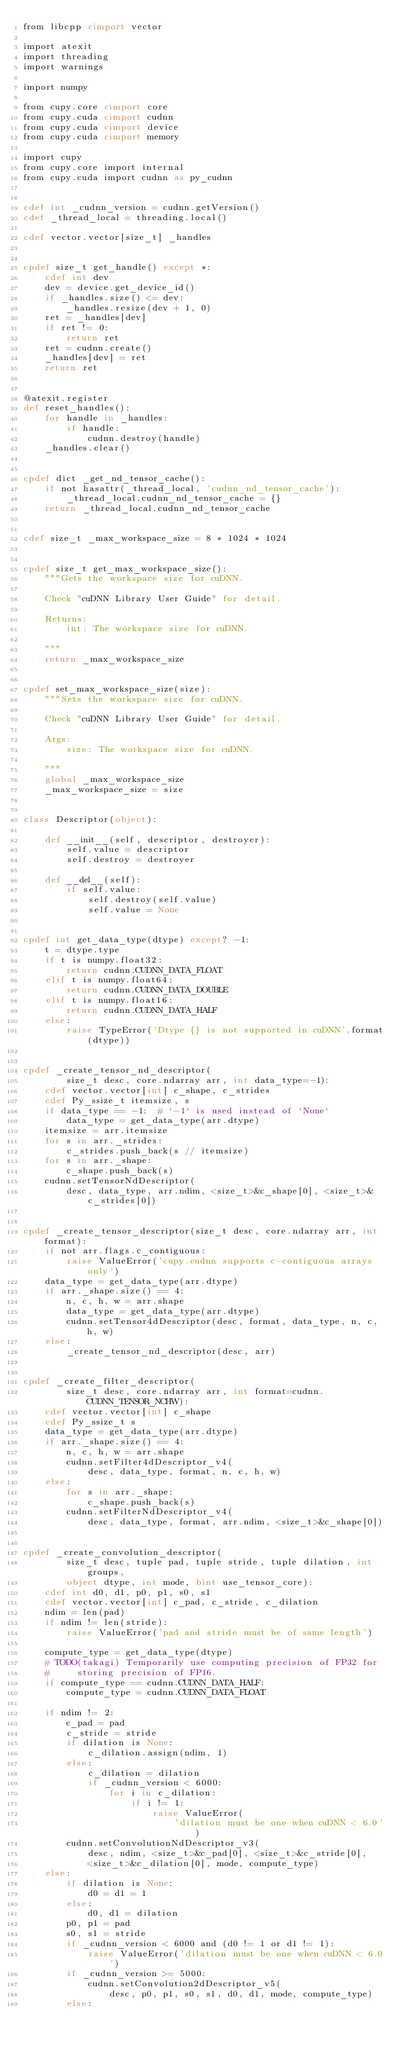<code> <loc_0><loc_0><loc_500><loc_500><_Cython_>from libcpp cimport vector

import atexit
import threading
import warnings

import numpy

from cupy.core cimport core
from cupy.cuda cimport cudnn
from cupy.cuda cimport device
from cupy.cuda cimport memory

import cupy
from cupy.core import internal
from cupy.cuda import cudnn as py_cudnn


cdef int _cudnn_version = cudnn.getVersion()
cdef _thread_local = threading.local()

cdef vector.vector[size_t] _handles


cpdef size_t get_handle() except *:
    cdef int dev
    dev = device.get_device_id()
    if _handles.size() <= dev:
        _handles.resize(dev + 1, 0)
    ret = _handles[dev]
    if ret != 0:
        return ret
    ret = cudnn.create()
    _handles[dev] = ret
    return ret


@atexit.register
def reset_handles():
    for handle in _handles:
        if handle:
            cudnn.destroy(handle)
    _handles.clear()


cpdef dict _get_nd_tensor_cache():
    if not hasattr(_thread_local, 'cudnn_nd_tensor_cache'):
        _thread_local.cudnn_nd_tensor_cache = {}
    return _thread_local.cudnn_nd_tensor_cache


cdef size_t _max_workspace_size = 8 * 1024 * 1024


cpdef size_t get_max_workspace_size():
    """Gets the workspace size for cuDNN.

    Check "cuDNN Library User Guide" for detail.

    Returns:
        int: The workspace size for cuDNN.

    """
    return _max_workspace_size


cpdef set_max_workspace_size(size):
    """Sets the workspace size for cuDNN.

    Check "cuDNN Library User Guide" for detail.

    Args:
        size: The workspace size for cuDNN.

    """
    global _max_workspace_size
    _max_workspace_size = size


class Descriptor(object):

    def __init__(self, descriptor, destroyer):
        self.value = descriptor
        self.destroy = destroyer

    def __del__(self):
        if self.value:
            self.destroy(self.value)
            self.value = None


cpdef int get_data_type(dtype) except? -1:
    t = dtype.type
    if t is numpy.float32:
        return cudnn.CUDNN_DATA_FLOAT
    elif t is numpy.float64:
        return cudnn.CUDNN_DATA_DOUBLE
    elif t is numpy.float16:
        return cudnn.CUDNN_DATA_HALF
    else:
        raise TypeError('Dtype {} is not supported in cuDNN'.format(dtype))


cpdef _create_tensor_nd_descriptor(
        size_t desc, core.ndarray arr, int data_type=-1):
    cdef vector.vector[int] c_shape, c_strides
    cdef Py_ssize_t itemsize, s
    if data_type == -1:  # `-1` is used instead of `None`
        data_type = get_data_type(arr.dtype)
    itemsize = arr.itemsize
    for s in arr._strides:
        c_strides.push_back(s // itemsize)
    for s in arr._shape:
        c_shape.push_back(s)
    cudnn.setTensorNdDescriptor(
        desc, data_type, arr.ndim, <size_t>&c_shape[0], <size_t>&c_strides[0])


cpdef _create_tensor_descriptor(size_t desc, core.ndarray arr, int format):
    if not arr.flags.c_contiguous:
        raise ValueError('cupy.cudnn supports c-contiguous arrays only')
    data_type = get_data_type(arr.dtype)
    if arr._shape.size() == 4:
        n, c, h, w = arr.shape
        data_type = get_data_type(arr.dtype)
        cudnn.setTensor4dDescriptor(desc, format, data_type, n, c, h, w)
    else:
        _create_tensor_nd_descriptor(desc, arr)


cpdef _create_filter_descriptor(
        size_t desc, core.ndarray arr, int format=cudnn.CUDNN_TENSOR_NCHW):
    cdef vector.vector[int] c_shape
    cdef Py_ssize_t s
    data_type = get_data_type(arr.dtype)
    if arr._shape.size() == 4:
        n, c, h, w = arr.shape
        cudnn.setFilter4dDescriptor_v4(
            desc, data_type, format, n, c, h, w)
    else:
        for s in arr._shape:
            c_shape.push_back(s)
        cudnn.setFilterNdDescriptor_v4(
            desc, data_type, format, arr.ndim, <size_t>&c_shape[0])


cpdef _create_convolution_descriptor(
        size_t desc, tuple pad, tuple stride, tuple dilation, int groups,
        object dtype, int mode, bint use_tensor_core):
    cdef int d0, d1, p0, p1, s0, s1
    cdef vector.vector[int] c_pad, c_stride, c_dilation
    ndim = len(pad)
    if ndim != len(stride):
        raise ValueError('pad and stride must be of same length')

    compute_type = get_data_type(dtype)
    # TODO(takagi) Temporarily use computing precision of FP32 for
    #     storing precision of FP16.
    if compute_type == cudnn.CUDNN_DATA_HALF:
        compute_type = cudnn.CUDNN_DATA_FLOAT

    if ndim != 2:
        c_pad = pad
        c_stride = stride
        if dilation is None:
            c_dilation.assign(ndim, 1)
        else:
            c_dilation = dilation
            if _cudnn_version < 6000:
                for i in c_dilation:
                    if i != 1:
                        raise ValueError(
                            'dilation must be one when cuDNN < 6.0')
        cudnn.setConvolutionNdDescriptor_v3(
            desc, ndim, <size_t>&c_pad[0], <size_t>&c_stride[0],
            <size_t>&c_dilation[0], mode, compute_type)
    else:
        if dilation is None:
            d0 = d1 = 1
        else:
            d0, d1 = dilation
        p0, p1 = pad
        s0, s1 = stride
        if _cudnn_version < 6000 and (d0 != 1 or d1 != 1):
            raise ValueError('dilation must be one when cuDNN < 6.0')
        if _cudnn_version >= 5000:
            cudnn.setConvolution2dDescriptor_v5(
                desc, p0, p1, s0, s1, d0, d1, mode, compute_type)
        else:</code> 